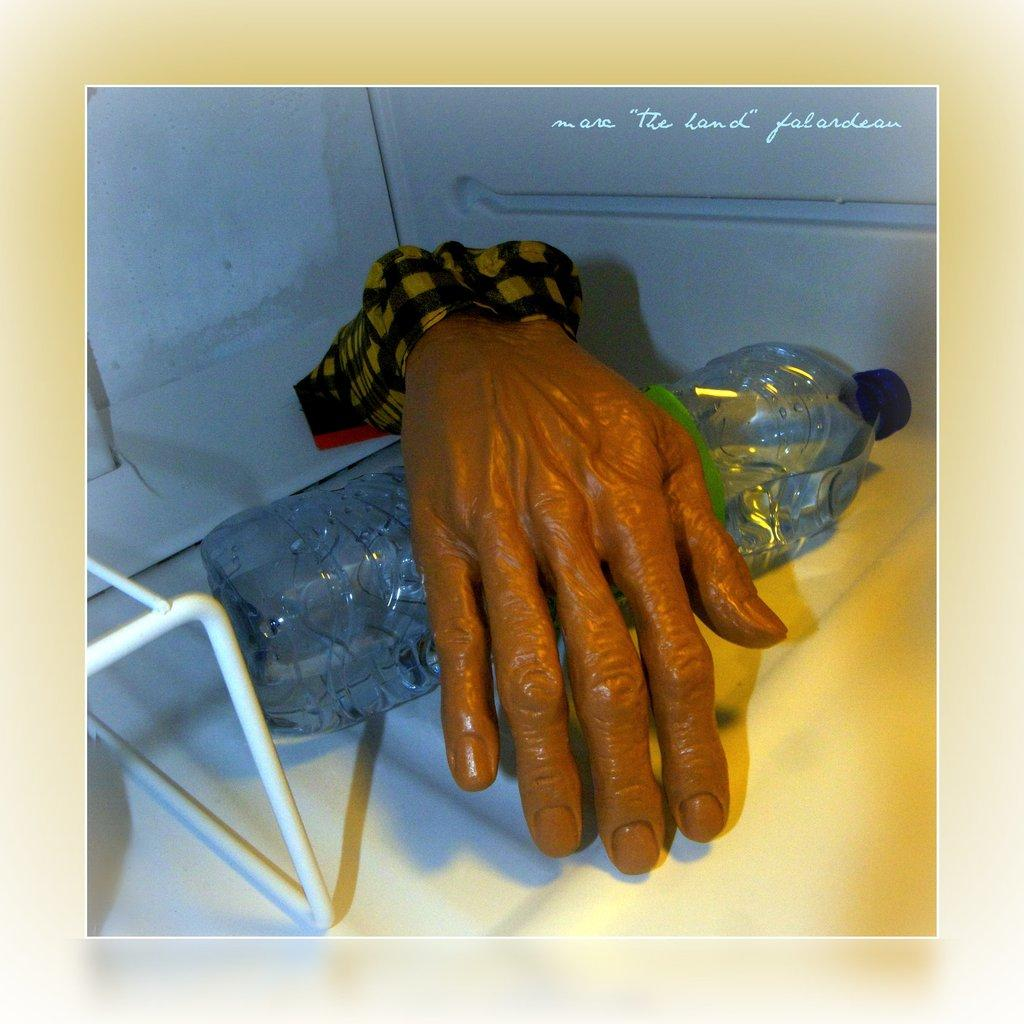What is the main object in the center of the image? There is a water bottle in the center of the image. Can you describe any other elements in the image? A person's hand is visible in the image. What type of island can be seen in the background of the image? There is no island visible in the image; it only features a water bottle and a person's hand. 